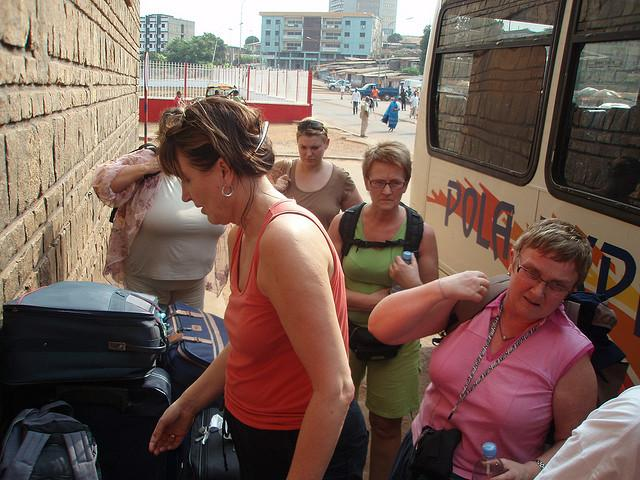What are the buildings in the background likely used for? Please explain your reasoning. private dwellings. The buildings appear to be apartment buildings based on their design and the repeated pattern. apartments are used as answer a. 